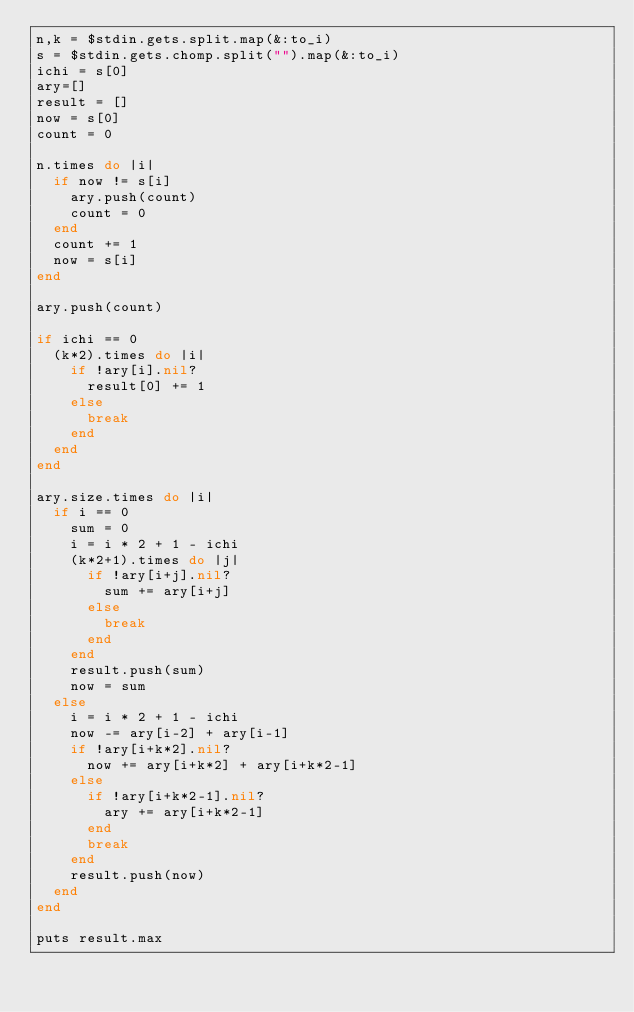Convert code to text. <code><loc_0><loc_0><loc_500><loc_500><_Ruby_>n,k = $stdin.gets.split.map(&:to_i)
s = $stdin.gets.chomp.split("").map(&:to_i)
ichi = s[0]
ary=[]
result = []
now = s[0]
count = 0
 
n.times do |i|
  if now != s[i]
    ary.push(count)
    count = 0
  end
  count += 1
  now = s[i]
end
 
ary.push(count)
 
if ichi == 0
  (k*2).times do |i|
    if !ary[i].nil?
      result[0] += 1
    else
      break
    end
  end
end
 
ary.size.times do |i|
  if i == 0
    sum = 0
    i = i * 2 + 1 - ichi
    (k*2+1).times do |j|
      if !ary[i+j].nil?
        sum += ary[i+j]
      else
        break
      end
    end
    result.push(sum)
    now = sum
  else
    i = i * 2 + 1 - ichi
    now -= ary[i-2] + ary[i-1]
    if !ary[i+k*2].nil?
      now += ary[i+k*2] + ary[i+k*2-1]
    else
      if !ary[i+k*2-1].nil?
        ary += ary[i+k*2-1]
      end
      break
    end
    result.push(now)
  end
end
 
puts result.max 
</code> 